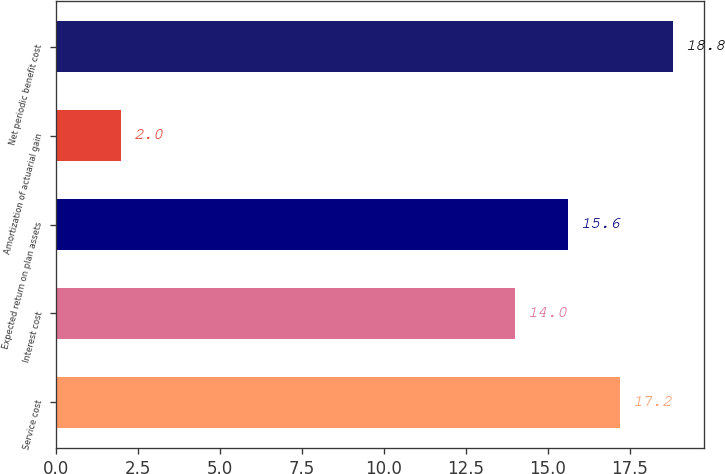Convert chart. <chart><loc_0><loc_0><loc_500><loc_500><bar_chart><fcel>Service cost<fcel>Interest cost<fcel>Expected return on plan assets<fcel>Amortization of actuarial gain<fcel>Net periodic benefit cost<nl><fcel>17.2<fcel>14<fcel>15.6<fcel>2<fcel>18.8<nl></chart> 